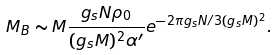<formula> <loc_0><loc_0><loc_500><loc_500>M _ { B } \sim M \frac { g _ { s } N \rho _ { 0 } } { ( g _ { s } M ) ^ { 2 } \alpha ^ { \prime } } e ^ { - 2 \pi g _ { s } N / 3 ( g _ { s } M ) ^ { 2 } } .</formula> 